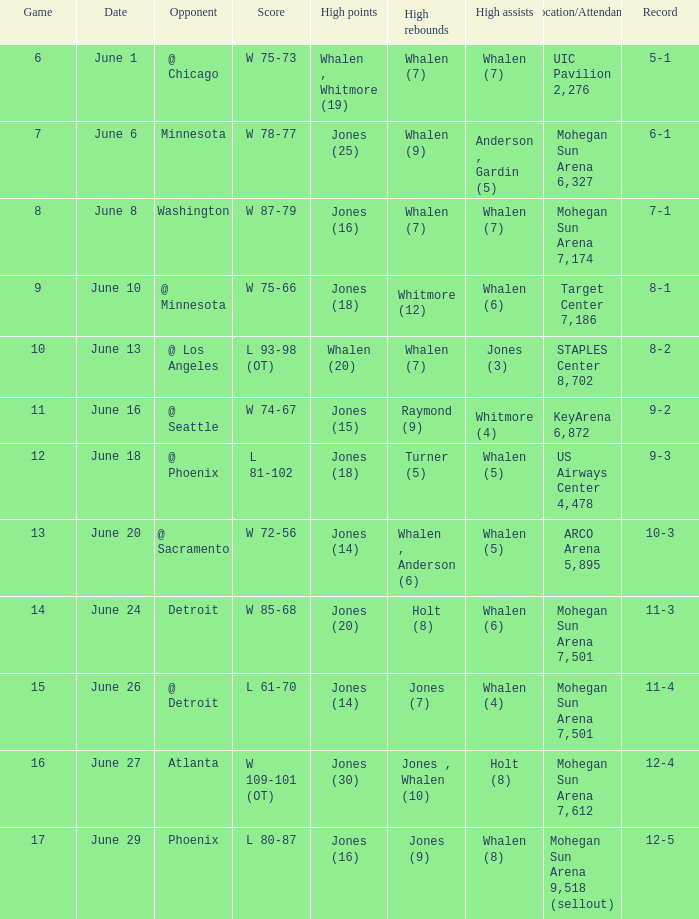What is the position/participation when the record is 9-2? KeyArena 6,872. 